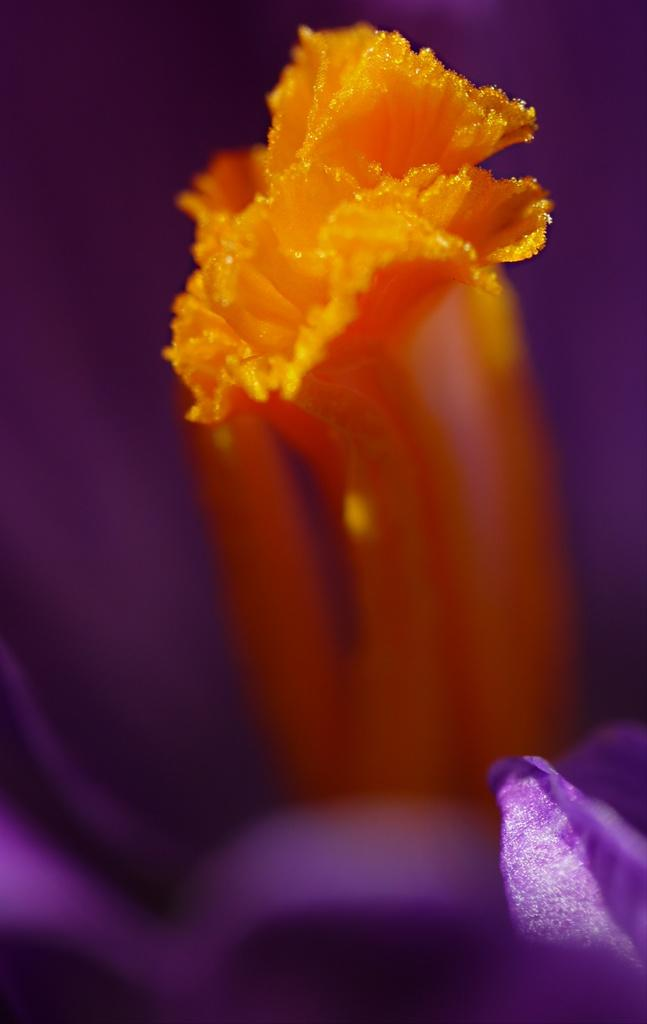What type of flowers can be seen in the image? There is an orange flower and a purple flower in the image. Where are the flowers located in the image? Both flowers are located at the bottom of the image. How does the clam contribute to the image? There is no clam present in the image; it only features orange and purple flowers. 